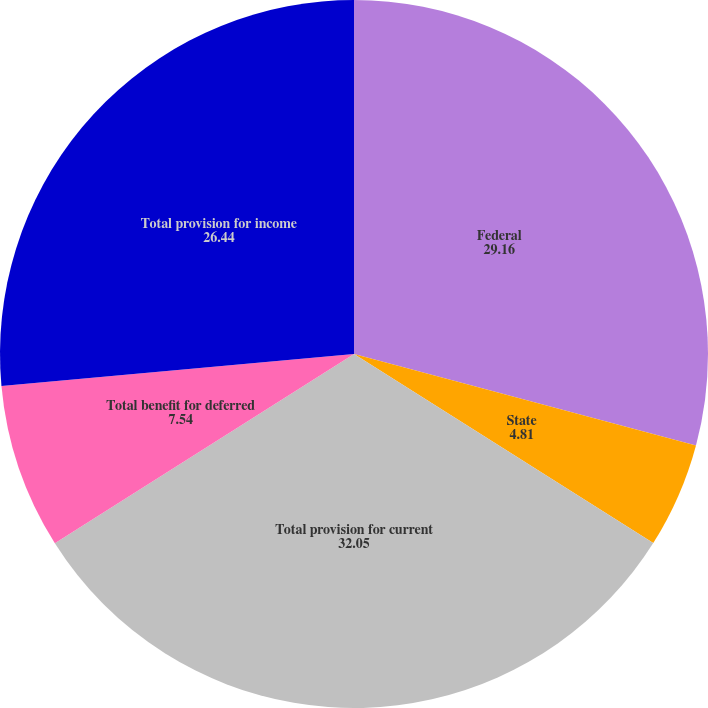Convert chart. <chart><loc_0><loc_0><loc_500><loc_500><pie_chart><fcel>Federal<fcel>State<fcel>Total provision for current<fcel>Total benefit for deferred<fcel>Total provision for income<nl><fcel>29.16%<fcel>4.81%<fcel>32.05%<fcel>7.54%<fcel>26.44%<nl></chart> 